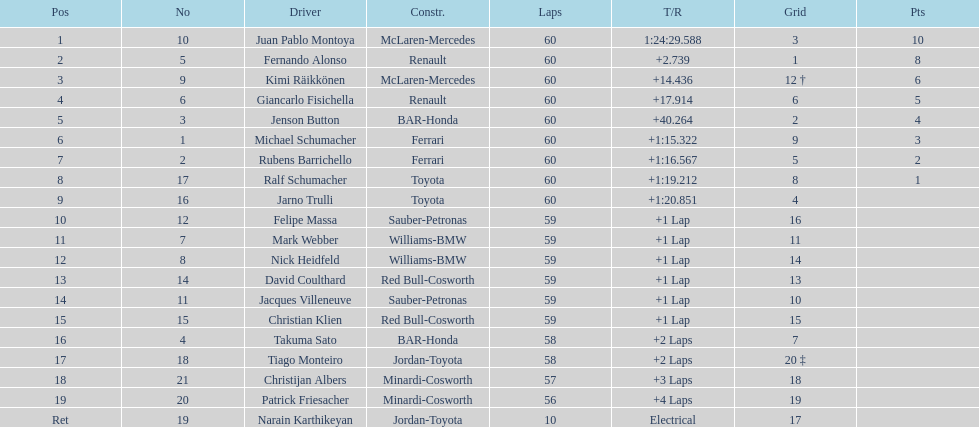How many drivers from germany? 3. 